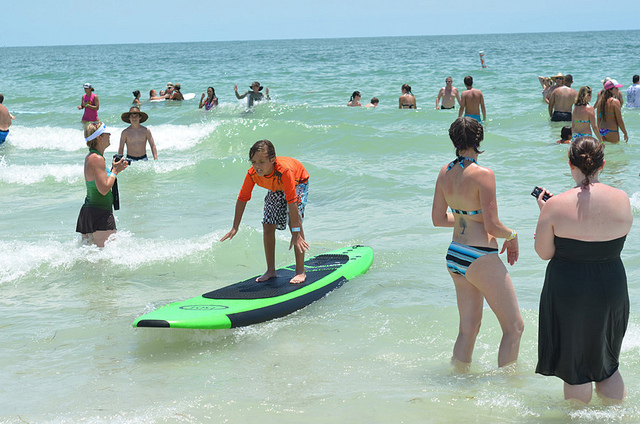Imagine telling someone who's never seen the ocean about this image. What would you say? This image captures a lively beach scene where people are enjoying their time in the ocean. The water glistens under the bright sun, and gentle waves provide the perfect setting for swimming and surfing. People of all ages are having fun, laughing, and creating wonderful memories together. The vast horizon meets the clear blue sky, and the beach is filled with vibrant energy as everyone revels in the beauty of nature. 